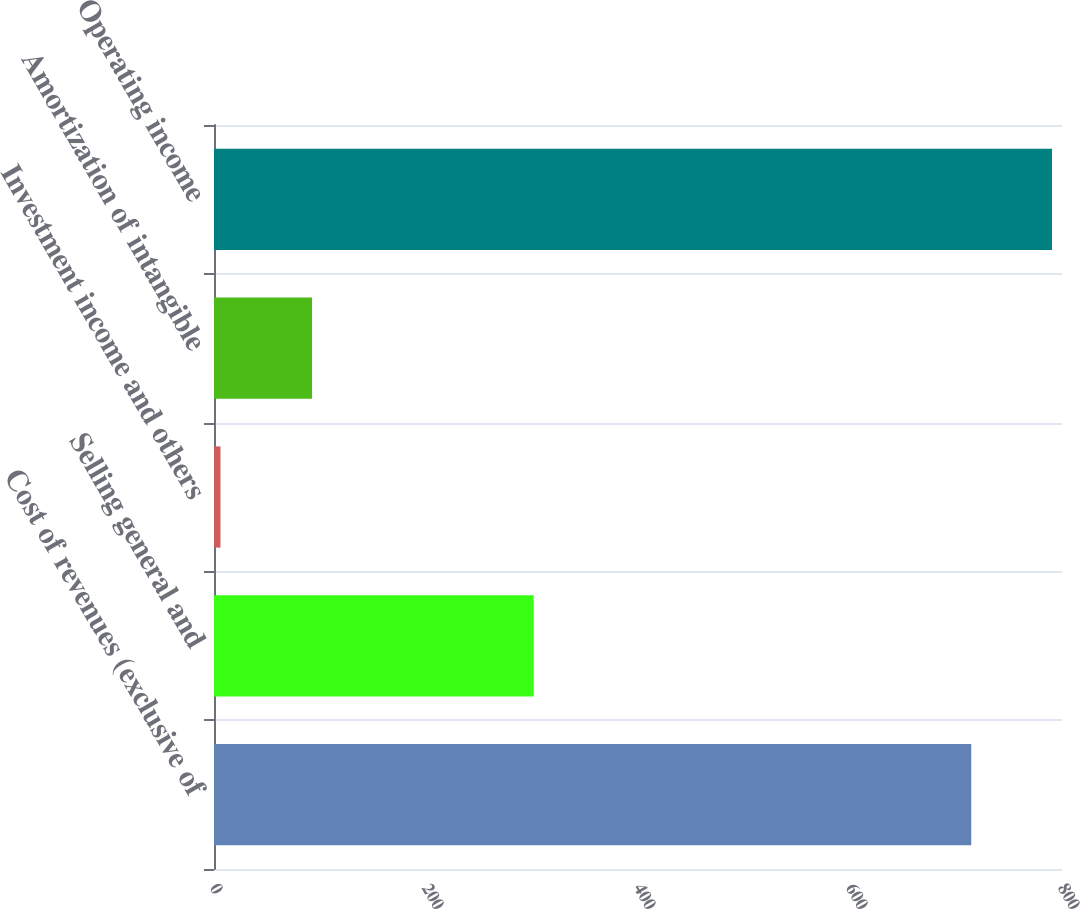<chart> <loc_0><loc_0><loc_500><loc_500><bar_chart><fcel>Cost of revenues (exclusive of<fcel>Selling general and<fcel>Investment income and others<fcel>Amortization of intangible<fcel>Operating income<nl><fcel>714.4<fcel>301.6<fcel>6.1<fcel>92.5<fcel>790.55<nl></chart> 